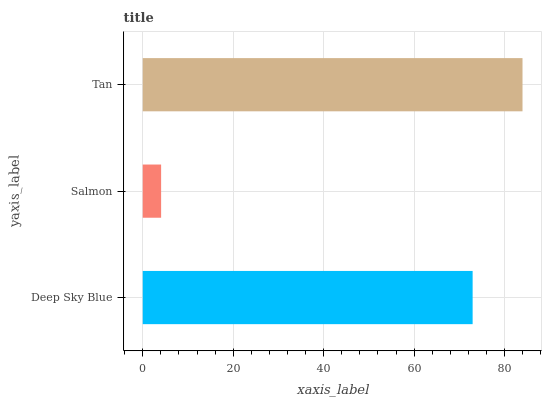Is Salmon the minimum?
Answer yes or no. Yes. Is Tan the maximum?
Answer yes or no. Yes. Is Tan the minimum?
Answer yes or no. No. Is Salmon the maximum?
Answer yes or no. No. Is Tan greater than Salmon?
Answer yes or no. Yes. Is Salmon less than Tan?
Answer yes or no. Yes. Is Salmon greater than Tan?
Answer yes or no. No. Is Tan less than Salmon?
Answer yes or no. No. Is Deep Sky Blue the high median?
Answer yes or no. Yes. Is Deep Sky Blue the low median?
Answer yes or no. Yes. Is Salmon the high median?
Answer yes or no. No. Is Salmon the low median?
Answer yes or no. No. 